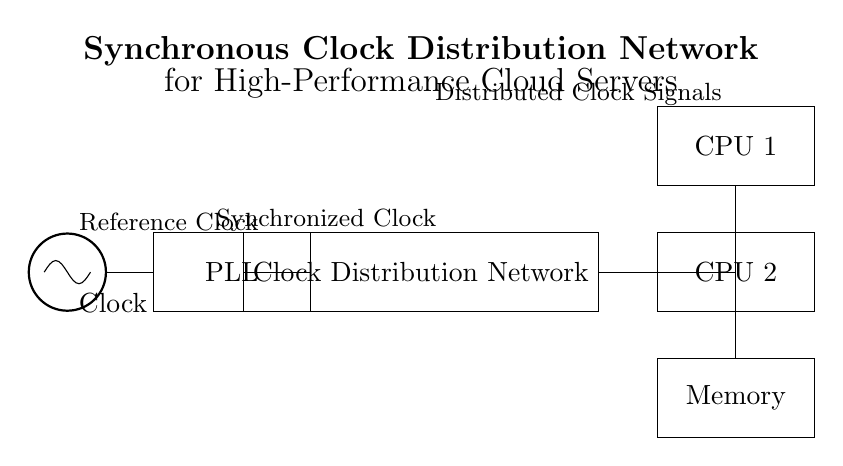What is the main source of the clock signal? The oscillator is the main source of the clock signal in the circuit. It is represented at the left side of the diagram, indicating its role in generating the reference clock.
Answer: Oscillator What follows the oscillator in the circuit? A Phase-Locked Loop (PLL) follows the oscillator, as depicted to the right of the oscillator. The PLL synchronizes the clock signal to ensure it is stable and has the desired frequency characteristics.
Answer: PLL How many CPUs are connected to the clock distribution network? There are two CPUs connected to the clock distribution network, shown as CPU 1 and CPU 2 in the diagram. Both are illustrated below the clock distribution network block.
Answer: Two What type of network is used to distribute clock signals? A clock distribution network is utilized in the circuit to distribute synchronized clock signals to various components like CPUs and memory. It ensures that all parts of the system operate in sync.
Answer: Clock Distribution Network What are the components directly receiving the clock signals? The components receiving the clock signals are identified as CPU 1, CPU 2, and Memory in the circuit diagram. Each component is linked to the clock distribution network, indicating they all get the synchronized clock signals.
Answer: CPU 1, CPU 2, Memory How is the clock distributed to CPU 1? The clock is distributed to CPU 1 through a dashed line from the clock distribution network, showing that it connects in a non-linear fashion to CPU 1. This suggests a specific routing path for the clock signal from the CDN.
Answer: Non-linear connection What is the function of the PLL in this circuit? The PLL's function is to synchronize the clock signal derived from the oscillator, ensuring that the output clock signal's frequency and phase are aligned with the reference clock signal.
Answer: Synchronization 